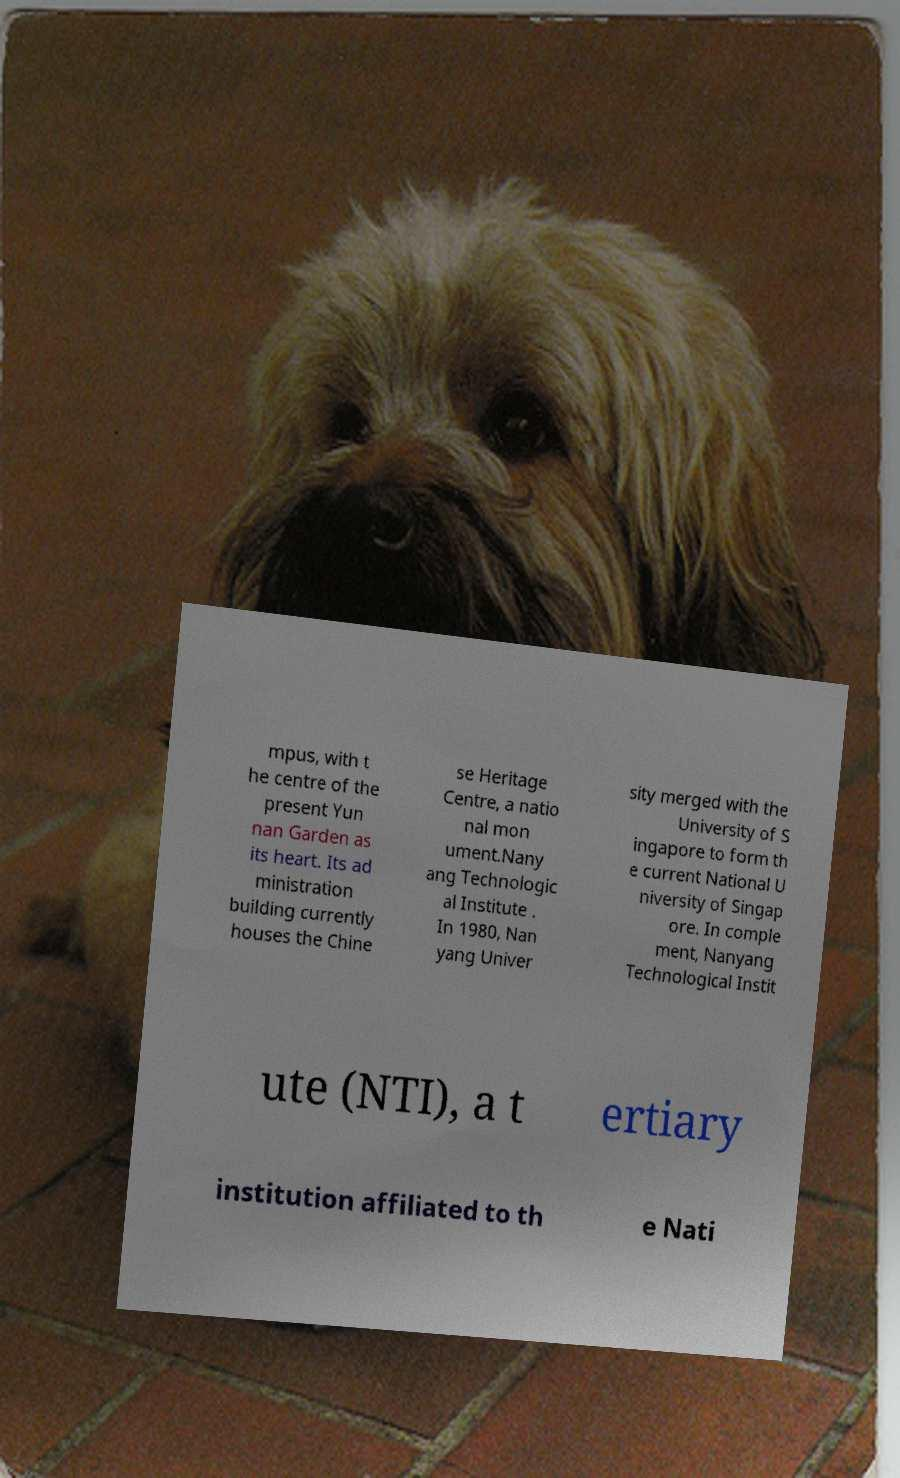Please identify and transcribe the text found in this image. mpus, with t he centre of the present Yun nan Garden as its heart. Its ad ministration building currently houses the Chine se Heritage Centre, a natio nal mon ument.Nany ang Technologic al Institute . In 1980, Nan yang Univer sity merged with the University of S ingapore to form th e current National U niversity of Singap ore. In comple ment, Nanyang Technological Instit ute (NTI), a t ertiary institution affiliated to th e Nati 